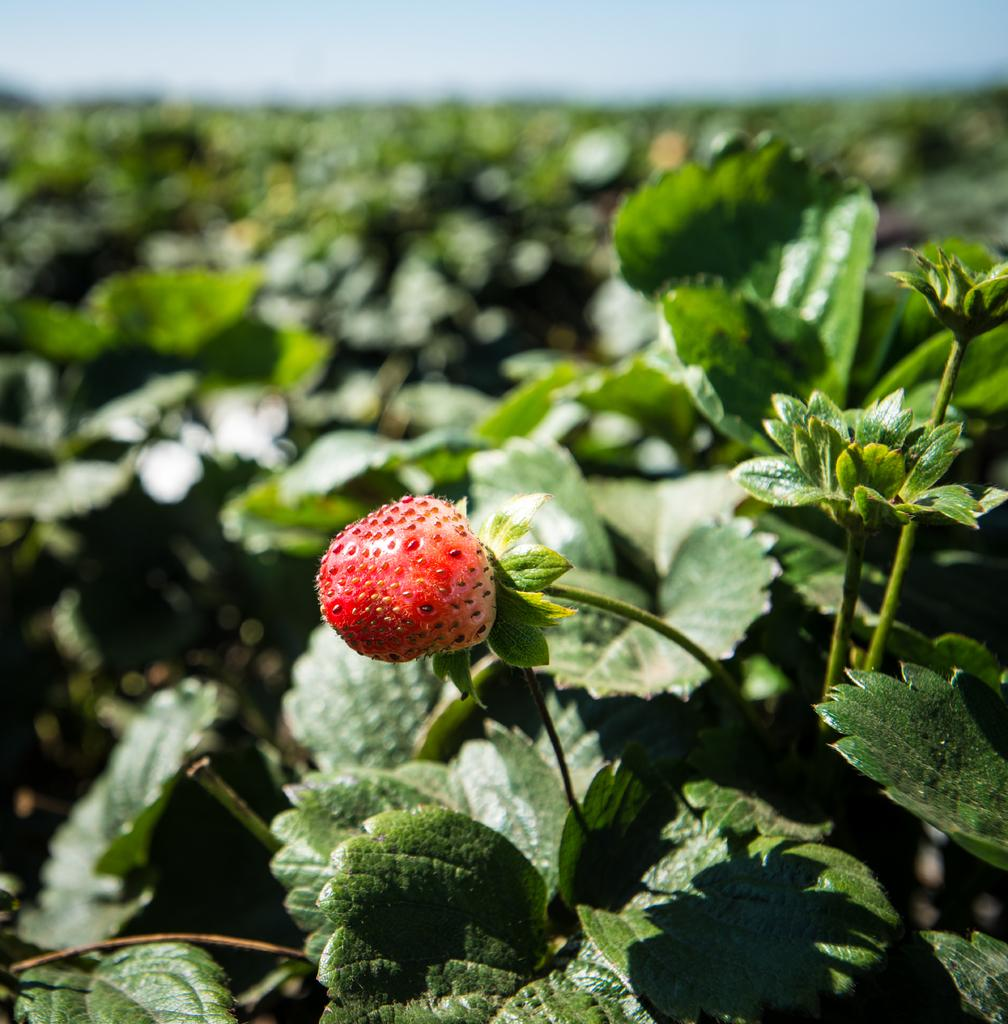What type of living organisms can be seen in the image? Plants and fruits are visible in the image. What is visible at the top of the image? The sky is visible at the top of the image. How is the background of the image depicted? The background of the image is slightly blurred. Can you tell me how many snails are crawling on the door in the image? There is no door or snails present in the image; it features plants, fruits, and a blurred background. What type of shop can be seen in the image? There is no shop present in the image. 